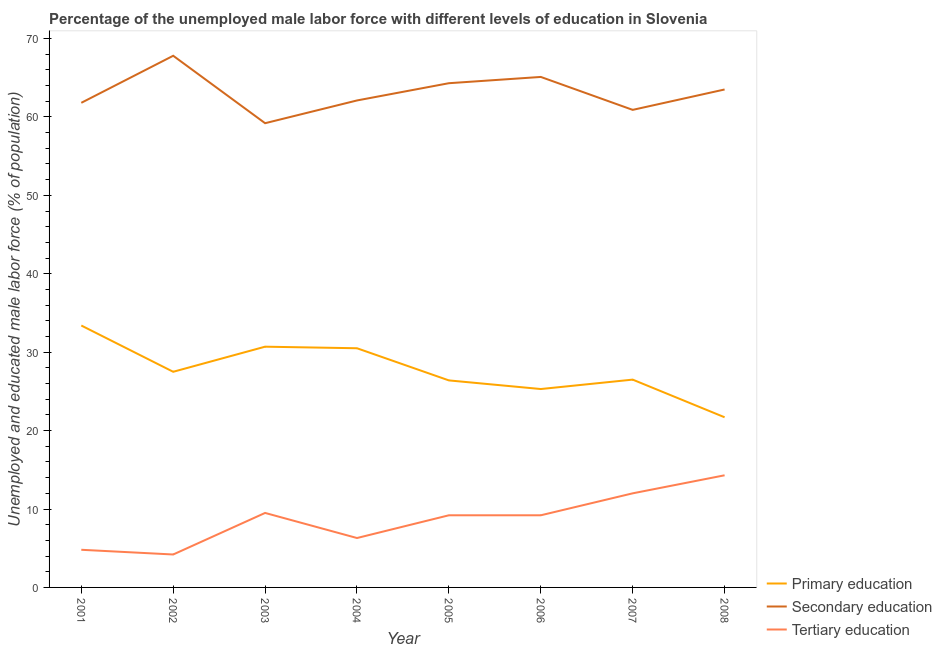How many different coloured lines are there?
Your response must be concise. 3. Across all years, what is the maximum percentage of male labor force who received secondary education?
Your response must be concise. 67.8. Across all years, what is the minimum percentage of male labor force who received secondary education?
Provide a succinct answer. 59.2. In which year was the percentage of male labor force who received secondary education maximum?
Your answer should be very brief. 2002. In which year was the percentage of male labor force who received tertiary education minimum?
Give a very brief answer. 2002. What is the total percentage of male labor force who received primary education in the graph?
Offer a very short reply. 222. What is the difference between the percentage of male labor force who received tertiary education in 2004 and that in 2007?
Offer a terse response. -5.7. What is the difference between the percentage of male labor force who received tertiary education in 2008 and the percentage of male labor force who received primary education in 2003?
Ensure brevity in your answer.  -16.4. What is the average percentage of male labor force who received secondary education per year?
Offer a terse response. 63.09. In the year 2002, what is the difference between the percentage of male labor force who received primary education and percentage of male labor force who received secondary education?
Ensure brevity in your answer.  -40.3. In how many years, is the percentage of male labor force who received tertiary education greater than 40 %?
Keep it short and to the point. 0. What is the ratio of the percentage of male labor force who received tertiary education in 2001 to that in 2004?
Keep it short and to the point. 0.76. Is the percentage of male labor force who received tertiary education in 2004 less than that in 2007?
Keep it short and to the point. Yes. What is the difference between the highest and the second highest percentage of male labor force who received secondary education?
Give a very brief answer. 2.7. What is the difference between the highest and the lowest percentage of male labor force who received tertiary education?
Provide a succinct answer. 10.1. Is the sum of the percentage of male labor force who received tertiary education in 2003 and 2007 greater than the maximum percentage of male labor force who received secondary education across all years?
Offer a terse response. No. Does the percentage of male labor force who received primary education monotonically increase over the years?
Provide a succinct answer. No. Is the percentage of male labor force who received tertiary education strictly less than the percentage of male labor force who received primary education over the years?
Keep it short and to the point. Yes. How many lines are there?
Provide a short and direct response. 3. Are the values on the major ticks of Y-axis written in scientific E-notation?
Make the answer very short. No. Does the graph contain any zero values?
Your answer should be very brief. No. Does the graph contain grids?
Your response must be concise. No. What is the title of the graph?
Provide a short and direct response. Percentage of the unemployed male labor force with different levels of education in Slovenia. What is the label or title of the X-axis?
Provide a short and direct response. Year. What is the label or title of the Y-axis?
Offer a very short reply. Unemployed and educated male labor force (% of population). What is the Unemployed and educated male labor force (% of population) in Primary education in 2001?
Your answer should be compact. 33.4. What is the Unemployed and educated male labor force (% of population) in Secondary education in 2001?
Offer a very short reply. 61.8. What is the Unemployed and educated male labor force (% of population) in Tertiary education in 2001?
Offer a terse response. 4.8. What is the Unemployed and educated male labor force (% of population) in Secondary education in 2002?
Make the answer very short. 67.8. What is the Unemployed and educated male labor force (% of population) of Tertiary education in 2002?
Your response must be concise. 4.2. What is the Unemployed and educated male labor force (% of population) in Primary education in 2003?
Offer a very short reply. 30.7. What is the Unemployed and educated male labor force (% of population) of Secondary education in 2003?
Your answer should be compact. 59.2. What is the Unemployed and educated male labor force (% of population) in Primary education in 2004?
Your answer should be compact. 30.5. What is the Unemployed and educated male labor force (% of population) in Secondary education in 2004?
Keep it short and to the point. 62.1. What is the Unemployed and educated male labor force (% of population) in Tertiary education in 2004?
Keep it short and to the point. 6.3. What is the Unemployed and educated male labor force (% of population) in Primary education in 2005?
Offer a very short reply. 26.4. What is the Unemployed and educated male labor force (% of population) of Secondary education in 2005?
Your response must be concise. 64.3. What is the Unemployed and educated male labor force (% of population) in Tertiary education in 2005?
Your answer should be compact. 9.2. What is the Unemployed and educated male labor force (% of population) of Primary education in 2006?
Keep it short and to the point. 25.3. What is the Unemployed and educated male labor force (% of population) of Secondary education in 2006?
Offer a very short reply. 65.1. What is the Unemployed and educated male labor force (% of population) in Tertiary education in 2006?
Provide a succinct answer. 9.2. What is the Unemployed and educated male labor force (% of population) in Secondary education in 2007?
Provide a succinct answer. 60.9. What is the Unemployed and educated male labor force (% of population) of Primary education in 2008?
Your answer should be very brief. 21.7. What is the Unemployed and educated male labor force (% of population) in Secondary education in 2008?
Keep it short and to the point. 63.5. What is the Unemployed and educated male labor force (% of population) in Tertiary education in 2008?
Your response must be concise. 14.3. Across all years, what is the maximum Unemployed and educated male labor force (% of population) in Primary education?
Your answer should be compact. 33.4. Across all years, what is the maximum Unemployed and educated male labor force (% of population) of Secondary education?
Make the answer very short. 67.8. Across all years, what is the maximum Unemployed and educated male labor force (% of population) in Tertiary education?
Provide a succinct answer. 14.3. Across all years, what is the minimum Unemployed and educated male labor force (% of population) in Primary education?
Offer a terse response. 21.7. Across all years, what is the minimum Unemployed and educated male labor force (% of population) in Secondary education?
Keep it short and to the point. 59.2. Across all years, what is the minimum Unemployed and educated male labor force (% of population) of Tertiary education?
Ensure brevity in your answer.  4.2. What is the total Unemployed and educated male labor force (% of population) of Primary education in the graph?
Your answer should be very brief. 222. What is the total Unemployed and educated male labor force (% of population) of Secondary education in the graph?
Offer a terse response. 504.7. What is the total Unemployed and educated male labor force (% of population) of Tertiary education in the graph?
Provide a short and direct response. 69.5. What is the difference between the Unemployed and educated male labor force (% of population) of Secondary education in 2001 and that in 2002?
Give a very brief answer. -6. What is the difference between the Unemployed and educated male labor force (% of population) of Secondary education in 2001 and that in 2003?
Offer a very short reply. 2.6. What is the difference between the Unemployed and educated male labor force (% of population) of Tertiary education in 2001 and that in 2003?
Provide a succinct answer. -4.7. What is the difference between the Unemployed and educated male labor force (% of population) in Secondary education in 2001 and that in 2004?
Provide a short and direct response. -0.3. What is the difference between the Unemployed and educated male labor force (% of population) of Secondary education in 2001 and that in 2005?
Your answer should be compact. -2.5. What is the difference between the Unemployed and educated male labor force (% of population) in Tertiary education in 2001 and that in 2005?
Provide a succinct answer. -4.4. What is the difference between the Unemployed and educated male labor force (% of population) in Primary education in 2001 and that in 2006?
Offer a very short reply. 8.1. What is the difference between the Unemployed and educated male labor force (% of population) of Secondary education in 2001 and that in 2006?
Your answer should be compact. -3.3. What is the difference between the Unemployed and educated male labor force (% of population) in Secondary education in 2001 and that in 2007?
Offer a very short reply. 0.9. What is the difference between the Unemployed and educated male labor force (% of population) of Tertiary education in 2001 and that in 2007?
Make the answer very short. -7.2. What is the difference between the Unemployed and educated male labor force (% of population) of Primary education in 2001 and that in 2008?
Ensure brevity in your answer.  11.7. What is the difference between the Unemployed and educated male labor force (% of population) of Tertiary education in 2002 and that in 2003?
Your response must be concise. -5.3. What is the difference between the Unemployed and educated male labor force (% of population) of Secondary education in 2002 and that in 2004?
Make the answer very short. 5.7. What is the difference between the Unemployed and educated male labor force (% of population) in Tertiary education in 2002 and that in 2004?
Your answer should be very brief. -2.1. What is the difference between the Unemployed and educated male labor force (% of population) in Secondary education in 2002 and that in 2005?
Your answer should be compact. 3.5. What is the difference between the Unemployed and educated male labor force (% of population) in Primary education in 2002 and that in 2006?
Make the answer very short. 2.2. What is the difference between the Unemployed and educated male labor force (% of population) in Primary education in 2002 and that in 2007?
Ensure brevity in your answer.  1. What is the difference between the Unemployed and educated male labor force (% of population) of Secondary education in 2002 and that in 2007?
Keep it short and to the point. 6.9. What is the difference between the Unemployed and educated male labor force (% of population) of Primary education in 2002 and that in 2008?
Your answer should be compact. 5.8. What is the difference between the Unemployed and educated male labor force (% of population) in Secondary education in 2002 and that in 2008?
Your answer should be very brief. 4.3. What is the difference between the Unemployed and educated male labor force (% of population) in Tertiary education in 2002 and that in 2008?
Ensure brevity in your answer.  -10.1. What is the difference between the Unemployed and educated male labor force (% of population) of Secondary education in 2003 and that in 2004?
Provide a succinct answer. -2.9. What is the difference between the Unemployed and educated male labor force (% of population) of Tertiary education in 2003 and that in 2004?
Offer a very short reply. 3.2. What is the difference between the Unemployed and educated male labor force (% of population) of Tertiary education in 2003 and that in 2005?
Offer a terse response. 0.3. What is the difference between the Unemployed and educated male labor force (% of population) in Primary education in 2003 and that in 2006?
Keep it short and to the point. 5.4. What is the difference between the Unemployed and educated male labor force (% of population) in Secondary education in 2003 and that in 2006?
Keep it short and to the point. -5.9. What is the difference between the Unemployed and educated male labor force (% of population) in Primary education in 2003 and that in 2007?
Make the answer very short. 4.2. What is the difference between the Unemployed and educated male labor force (% of population) in Secondary education in 2003 and that in 2007?
Offer a terse response. -1.7. What is the difference between the Unemployed and educated male labor force (% of population) in Tertiary education in 2003 and that in 2007?
Ensure brevity in your answer.  -2.5. What is the difference between the Unemployed and educated male labor force (% of population) in Primary education in 2003 and that in 2008?
Provide a succinct answer. 9. What is the difference between the Unemployed and educated male labor force (% of population) in Secondary education in 2003 and that in 2008?
Give a very brief answer. -4.3. What is the difference between the Unemployed and educated male labor force (% of population) in Tertiary education in 2003 and that in 2008?
Provide a short and direct response. -4.8. What is the difference between the Unemployed and educated male labor force (% of population) in Primary education in 2004 and that in 2005?
Give a very brief answer. 4.1. What is the difference between the Unemployed and educated male labor force (% of population) of Secondary education in 2004 and that in 2006?
Provide a succinct answer. -3. What is the difference between the Unemployed and educated male labor force (% of population) of Primary education in 2004 and that in 2007?
Provide a succinct answer. 4. What is the difference between the Unemployed and educated male labor force (% of population) of Secondary education in 2004 and that in 2007?
Ensure brevity in your answer.  1.2. What is the difference between the Unemployed and educated male labor force (% of population) in Tertiary education in 2004 and that in 2007?
Offer a very short reply. -5.7. What is the difference between the Unemployed and educated male labor force (% of population) of Secondary education in 2004 and that in 2008?
Give a very brief answer. -1.4. What is the difference between the Unemployed and educated male labor force (% of population) of Tertiary education in 2004 and that in 2008?
Give a very brief answer. -8. What is the difference between the Unemployed and educated male labor force (% of population) of Secondary education in 2005 and that in 2006?
Keep it short and to the point. -0.8. What is the difference between the Unemployed and educated male labor force (% of population) of Secondary education in 2005 and that in 2007?
Offer a very short reply. 3.4. What is the difference between the Unemployed and educated male labor force (% of population) of Tertiary education in 2005 and that in 2007?
Your answer should be compact. -2.8. What is the difference between the Unemployed and educated male labor force (% of population) of Tertiary education in 2005 and that in 2008?
Provide a short and direct response. -5.1. What is the difference between the Unemployed and educated male labor force (% of population) in Primary education in 2006 and that in 2007?
Provide a succinct answer. -1.2. What is the difference between the Unemployed and educated male labor force (% of population) of Secondary education in 2006 and that in 2008?
Your answer should be compact. 1.6. What is the difference between the Unemployed and educated male labor force (% of population) in Secondary education in 2007 and that in 2008?
Offer a very short reply. -2.6. What is the difference between the Unemployed and educated male labor force (% of population) of Primary education in 2001 and the Unemployed and educated male labor force (% of population) of Secondary education in 2002?
Your response must be concise. -34.4. What is the difference between the Unemployed and educated male labor force (% of population) in Primary education in 2001 and the Unemployed and educated male labor force (% of population) in Tertiary education in 2002?
Offer a very short reply. 29.2. What is the difference between the Unemployed and educated male labor force (% of population) in Secondary education in 2001 and the Unemployed and educated male labor force (% of population) in Tertiary education in 2002?
Offer a terse response. 57.6. What is the difference between the Unemployed and educated male labor force (% of population) of Primary education in 2001 and the Unemployed and educated male labor force (% of population) of Secondary education in 2003?
Your response must be concise. -25.8. What is the difference between the Unemployed and educated male labor force (% of population) in Primary education in 2001 and the Unemployed and educated male labor force (% of population) in Tertiary education in 2003?
Your answer should be very brief. 23.9. What is the difference between the Unemployed and educated male labor force (% of population) in Secondary education in 2001 and the Unemployed and educated male labor force (% of population) in Tertiary education in 2003?
Your answer should be very brief. 52.3. What is the difference between the Unemployed and educated male labor force (% of population) in Primary education in 2001 and the Unemployed and educated male labor force (% of population) in Secondary education in 2004?
Provide a succinct answer. -28.7. What is the difference between the Unemployed and educated male labor force (% of population) in Primary education in 2001 and the Unemployed and educated male labor force (% of population) in Tertiary education in 2004?
Keep it short and to the point. 27.1. What is the difference between the Unemployed and educated male labor force (% of population) in Secondary education in 2001 and the Unemployed and educated male labor force (% of population) in Tertiary education in 2004?
Give a very brief answer. 55.5. What is the difference between the Unemployed and educated male labor force (% of population) of Primary education in 2001 and the Unemployed and educated male labor force (% of population) of Secondary education in 2005?
Your answer should be compact. -30.9. What is the difference between the Unemployed and educated male labor force (% of population) in Primary education in 2001 and the Unemployed and educated male labor force (% of population) in Tertiary education in 2005?
Offer a very short reply. 24.2. What is the difference between the Unemployed and educated male labor force (% of population) of Secondary education in 2001 and the Unemployed and educated male labor force (% of population) of Tertiary education in 2005?
Provide a short and direct response. 52.6. What is the difference between the Unemployed and educated male labor force (% of population) of Primary education in 2001 and the Unemployed and educated male labor force (% of population) of Secondary education in 2006?
Offer a very short reply. -31.7. What is the difference between the Unemployed and educated male labor force (% of population) of Primary education in 2001 and the Unemployed and educated male labor force (% of population) of Tertiary education in 2006?
Your answer should be compact. 24.2. What is the difference between the Unemployed and educated male labor force (% of population) of Secondary education in 2001 and the Unemployed and educated male labor force (% of population) of Tertiary education in 2006?
Offer a terse response. 52.6. What is the difference between the Unemployed and educated male labor force (% of population) in Primary education in 2001 and the Unemployed and educated male labor force (% of population) in Secondary education in 2007?
Provide a short and direct response. -27.5. What is the difference between the Unemployed and educated male labor force (% of population) in Primary education in 2001 and the Unemployed and educated male labor force (% of population) in Tertiary education in 2007?
Keep it short and to the point. 21.4. What is the difference between the Unemployed and educated male labor force (% of population) of Secondary education in 2001 and the Unemployed and educated male labor force (% of population) of Tertiary education in 2007?
Offer a terse response. 49.8. What is the difference between the Unemployed and educated male labor force (% of population) of Primary education in 2001 and the Unemployed and educated male labor force (% of population) of Secondary education in 2008?
Keep it short and to the point. -30.1. What is the difference between the Unemployed and educated male labor force (% of population) in Secondary education in 2001 and the Unemployed and educated male labor force (% of population) in Tertiary education in 2008?
Provide a short and direct response. 47.5. What is the difference between the Unemployed and educated male labor force (% of population) of Primary education in 2002 and the Unemployed and educated male labor force (% of population) of Secondary education in 2003?
Your answer should be very brief. -31.7. What is the difference between the Unemployed and educated male labor force (% of population) in Secondary education in 2002 and the Unemployed and educated male labor force (% of population) in Tertiary education in 2003?
Make the answer very short. 58.3. What is the difference between the Unemployed and educated male labor force (% of population) of Primary education in 2002 and the Unemployed and educated male labor force (% of population) of Secondary education in 2004?
Provide a short and direct response. -34.6. What is the difference between the Unemployed and educated male labor force (% of population) of Primary education in 2002 and the Unemployed and educated male labor force (% of population) of Tertiary education in 2004?
Your response must be concise. 21.2. What is the difference between the Unemployed and educated male labor force (% of population) of Secondary education in 2002 and the Unemployed and educated male labor force (% of population) of Tertiary education in 2004?
Keep it short and to the point. 61.5. What is the difference between the Unemployed and educated male labor force (% of population) of Primary education in 2002 and the Unemployed and educated male labor force (% of population) of Secondary education in 2005?
Provide a succinct answer. -36.8. What is the difference between the Unemployed and educated male labor force (% of population) in Secondary education in 2002 and the Unemployed and educated male labor force (% of population) in Tertiary education in 2005?
Your answer should be very brief. 58.6. What is the difference between the Unemployed and educated male labor force (% of population) of Primary education in 2002 and the Unemployed and educated male labor force (% of population) of Secondary education in 2006?
Your answer should be compact. -37.6. What is the difference between the Unemployed and educated male labor force (% of population) in Secondary education in 2002 and the Unemployed and educated male labor force (% of population) in Tertiary education in 2006?
Your answer should be very brief. 58.6. What is the difference between the Unemployed and educated male labor force (% of population) in Primary education in 2002 and the Unemployed and educated male labor force (% of population) in Secondary education in 2007?
Provide a succinct answer. -33.4. What is the difference between the Unemployed and educated male labor force (% of population) in Primary education in 2002 and the Unemployed and educated male labor force (% of population) in Tertiary education in 2007?
Your answer should be very brief. 15.5. What is the difference between the Unemployed and educated male labor force (% of population) in Secondary education in 2002 and the Unemployed and educated male labor force (% of population) in Tertiary education in 2007?
Offer a terse response. 55.8. What is the difference between the Unemployed and educated male labor force (% of population) in Primary education in 2002 and the Unemployed and educated male labor force (% of population) in Secondary education in 2008?
Your answer should be compact. -36. What is the difference between the Unemployed and educated male labor force (% of population) of Primary education in 2002 and the Unemployed and educated male labor force (% of population) of Tertiary education in 2008?
Your answer should be very brief. 13.2. What is the difference between the Unemployed and educated male labor force (% of population) in Secondary education in 2002 and the Unemployed and educated male labor force (% of population) in Tertiary education in 2008?
Make the answer very short. 53.5. What is the difference between the Unemployed and educated male labor force (% of population) in Primary education in 2003 and the Unemployed and educated male labor force (% of population) in Secondary education in 2004?
Offer a very short reply. -31.4. What is the difference between the Unemployed and educated male labor force (% of population) of Primary education in 2003 and the Unemployed and educated male labor force (% of population) of Tertiary education in 2004?
Offer a terse response. 24.4. What is the difference between the Unemployed and educated male labor force (% of population) of Secondary education in 2003 and the Unemployed and educated male labor force (% of population) of Tertiary education in 2004?
Your response must be concise. 52.9. What is the difference between the Unemployed and educated male labor force (% of population) of Primary education in 2003 and the Unemployed and educated male labor force (% of population) of Secondary education in 2005?
Give a very brief answer. -33.6. What is the difference between the Unemployed and educated male labor force (% of population) in Secondary education in 2003 and the Unemployed and educated male labor force (% of population) in Tertiary education in 2005?
Your answer should be compact. 50. What is the difference between the Unemployed and educated male labor force (% of population) in Primary education in 2003 and the Unemployed and educated male labor force (% of population) in Secondary education in 2006?
Keep it short and to the point. -34.4. What is the difference between the Unemployed and educated male labor force (% of population) of Primary education in 2003 and the Unemployed and educated male labor force (% of population) of Secondary education in 2007?
Your answer should be very brief. -30.2. What is the difference between the Unemployed and educated male labor force (% of population) in Secondary education in 2003 and the Unemployed and educated male labor force (% of population) in Tertiary education in 2007?
Your answer should be very brief. 47.2. What is the difference between the Unemployed and educated male labor force (% of population) of Primary education in 2003 and the Unemployed and educated male labor force (% of population) of Secondary education in 2008?
Ensure brevity in your answer.  -32.8. What is the difference between the Unemployed and educated male labor force (% of population) in Secondary education in 2003 and the Unemployed and educated male labor force (% of population) in Tertiary education in 2008?
Ensure brevity in your answer.  44.9. What is the difference between the Unemployed and educated male labor force (% of population) of Primary education in 2004 and the Unemployed and educated male labor force (% of population) of Secondary education in 2005?
Give a very brief answer. -33.8. What is the difference between the Unemployed and educated male labor force (% of population) in Primary education in 2004 and the Unemployed and educated male labor force (% of population) in Tertiary education in 2005?
Make the answer very short. 21.3. What is the difference between the Unemployed and educated male labor force (% of population) of Secondary education in 2004 and the Unemployed and educated male labor force (% of population) of Tertiary education in 2005?
Your answer should be compact. 52.9. What is the difference between the Unemployed and educated male labor force (% of population) of Primary education in 2004 and the Unemployed and educated male labor force (% of population) of Secondary education in 2006?
Your response must be concise. -34.6. What is the difference between the Unemployed and educated male labor force (% of population) of Primary education in 2004 and the Unemployed and educated male labor force (% of population) of Tertiary education in 2006?
Your answer should be compact. 21.3. What is the difference between the Unemployed and educated male labor force (% of population) of Secondary education in 2004 and the Unemployed and educated male labor force (% of population) of Tertiary education in 2006?
Offer a very short reply. 52.9. What is the difference between the Unemployed and educated male labor force (% of population) of Primary education in 2004 and the Unemployed and educated male labor force (% of population) of Secondary education in 2007?
Provide a succinct answer. -30.4. What is the difference between the Unemployed and educated male labor force (% of population) in Secondary education in 2004 and the Unemployed and educated male labor force (% of population) in Tertiary education in 2007?
Provide a short and direct response. 50.1. What is the difference between the Unemployed and educated male labor force (% of population) in Primary education in 2004 and the Unemployed and educated male labor force (% of population) in Secondary education in 2008?
Your response must be concise. -33. What is the difference between the Unemployed and educated male labor force (% of population) in Secondary education in 2004 and the Unemployed and educated male labor force (% of population) in Tertiary education in 2008?
Make the answer very short. 47.8. What is the difference between the Unemployed and educated male labor force (% of population) of Primary education in 2005 and the Unemployed and educated male labor force (% of population) of Secondary education in 2006?
Your response must be concise. -38.7. What is the difference between the Unemployed and educated male labor force (% of population) in Secondary education in 2005 and the Unemployed and educated male labor force (% of population) in Tertiary education in 2006?
Provide a short and direct response. 55.1. What is the difference between the Unemployed and educated male labor force (% of population) of Primary education in 2005 and the Unemployed and educated male labor force (% of population) of Secondary education in 2007?
Provide a short and direct response. -34.5. What is the difference between the Unemployed and educated male labor force (% of population) in Secondary education in 2005 and the Unemployed and educated male labor force (% of population) in Tertiary education in 2007?
Offer a very short reply. 52.3. What is the difference between the Unemployed and educated male labor force (% of population) in Primary education in 2005 and the Unemployed and educated male labor force (% of population) in Secondary education in 2008?
Your answer should be compact. -37.1. What is the difference between the Unemployed and educated male labor force (% of population) of Primary education in 2005 and the Unemployed and educated male labor force (% of population) of Tertiary education in 2008?
Provide a short and direct response. 12.1. What is the difference between the Unemployed and educated male labor force (% of population) of Primary education in 2006 and the Unemployed and educated male labor force (% of population) of Secondary education in 2007?
Provide a succinct answer. -35.6. What is the difference between the Unemployed and educated male labor force (% of population) in Primary education in 2006 and the Unemployed and educated male labor force (% of population) in Tertiary education in 2007?
Offer a terse response. 13.3. What is the difference between the Unemployed and educated male labor force (% of population) of Secondary education in 2006 and the Unemployed and educated male labor force (% of population) of Tertiary education in 2007?
Provide a short and direct response. 53.1. What is the difference between the Unemployed and educated male labor force (% of population) in Primary education in 2006 and the Unemployed and educated male labor force (% of population) in Secondary education in 2008?
Provide a short and direct response. -38.2. What is the difference between the Unemployed and educated male labor force (% of population) of Primary education in 2006 and the Unemployed and educated male labor force (% of population) of Tertiary education in 2008?
Your answer should be very brief. 11. What is the difference between the Unemployed and educated male labor force (% of population) in Secondary education in 2006 and the Unemployed and educated male labor force (% of population) in Tertiary education in 2008?
Provide a succinct answer. 50.8. What is the difference between the Unemployed and educated male labor force (% of population) of Primary education in 2007 and the Unemployed and educated male labor force (% of population) of Secondary education in 2008?
Your answer should be compact. -37. What is the difference between the Unemployed and educated male labor force (% of population) in Primary education in 2007 and the Unemployed and educated male labor force (% of population) in Tertiary education in 2008?
Provide a short and direct response. 12.2. What is the difference between the Unemployed and educated male labor force (% of population) in Secondary education in 2007 and the Unemployed and educated male labor force (% of population) in Tertiary education in 2008?
Keep it short and to the point. 46.6. What is the average Unemployed and educated male labor force (% of population) in Primary education per year?
Your answer should be compact. 27.75. What is the average Unemployed and educated male labor force (% of population) in Secondary education per year?
Make the answer very short. 63.09. What is the average Unemployed and educated male labor force (% of population) of Tertiary education per year?
Provide a succinct answer. 8.69. In the year 2001, what is the difference between the Unemployed and educated male labor force (% of population) in Primary education and Unemployed and educated male labor force (% of population) in Secondary education?
Provide a short and direct response. -28.4. In the year 2001, what is the difference between the Unemployed and educated male labor force (% of population) of Primary education and Unemployed and educated male labor force (% of population) of Tertiary education?
Offer a terse response. 28.6. In the year 2002, what is the difference between the Unemployed and educated male labor force (% of population) in Primary education and Unemployed and educated male labor force (% of population) in Secondary education?
Give a very brief answer. -40.3. In the year 2002, what is the difference between the Unemployed and educated male labor force (% of population) of Primary education and Unemployed and educated male labor force (% of population) of Tertiary education?
Your answer should be compact. 23.3. In the year 2002, what is the difference between the Unemployed and educated male labor force (% of population) in Secondary education and Unemployed and educated male labor force (% of population) in Tertiary education?
Offer a very short reply. 63.6. In the year 2003, what is the difference between the Unemployed and educated male labor force (% of population) in Primary education and Unemployed and educated male labor force (% of population) in Secondary education?
Offer a very short reply. -28.5. In the year 2003, what is the difference between the Unemployed and educated male labor force (% of population) in Primary education and Unemployed and educated male labor force (% of population) in Tertiary education?
Keep it short and to the point. 21.2. In the year 2003, what is the difference between the Unemployed and educated male labor force (% of population) in Secondary education and Unemployed and educated male labor force (% of population) in Tertiary education?
Your answer should be very brief. 49.7. In the year 2004, what is the difference between the Unemployed and educated male labor force (% of population) of Primary education and Unemployed and educated male labor force (% of population) of Secondary education?
Provide a short and direct response. -31.6. In the year 2004, what is the difference between the Unemployed and educated male labor force (% of population) in Primary education and Unemployed and educated male labor force (% of population) in Tertiary education?
Offer a terse response. 24.2. In the year 2004, what is the difference between the Unemployed and educated male labor force (% of population) in Secondary education and Unemployed and educated male labor force (% of population) in Tertiary education?
Offer a very short reply. 55.8. In the year 2005, what is the difference between the Unemployed and educated male labor force (% of population) of Primary education and Unemployed and educated male labor force (% of population) of Secondary education?
Your answer should be very brief. -37.9. In the year 2005, what is the difference between the Unemployed and educated male labor force (% of population) of Primary education and Unemployed and educated male labor force (% of population) of Tertiary education?
Your answer should be very brief. 17.2. In the year 2005, what is the difference between the Unemployed and educated male labor force (% of population) in Secondary education and Unemployed and educated male labor force (% of population) in Tertiary education?
Offer a very short reply. 55.1. In the year 2006, what is the difference between the Unemployed and educated male labor force (% of population) in Primary education and Unemployed and educated male labor force (% of population) in Secondary education?
Keep it short and to the point. -39.8. In the year 2006, what is the difference between the Unemployed and educated male labor force (% of population) in Primary education and Unemployed and educated male labor force (% of population) in Tertiary education?
Provide a succinct answer. 16.1. In the year 2006, what is the difference between the Unemployed and educated male labor force (% of population) in Secondary education and Unemployed and educated male labor force (% of population) in Tertiary education?
Ensure brevity in your answer.  55.9. In the year 2007, what is the difference between the Unemployed and educated male labor force (% of population) in Primary education and Unemployed and educated male labor force (% of population) in Secondary education?
Make the answer very short. -34.4. In the year 2007, what is the difference between the Unemployed and educated male labor force (% of population) of Secondary education and Unemployed and educated male labor force (% of population) of Tertiary education?
Ensure brevity in your answer.  48.9. In the year 2008, what is the difference between the Unemployed and educated male labor force (% of population) in Primary education and Unemployed and educated male labor force (% of population) in Secondary education?
Provide a short and direct response. -41.8. In the year 2008, what is the difference between the Unemployed and educated male labor force (% of population) of Primary education and Unemployed and educated male labor force (% of population) of Tertiary education?
Give a very brief answer. 7.4. In the year 2008, what is the difference between the Unemployed and educated male labor force (% of population) of Secondary education and Unemployed and educated male labor force (% of population) of Tertiary education?
Give a very brief answer. 49.2. What is the ratio of the Unemployed and educated male labor force (% of population) of Primary education in 2001 to that in 2002?
Your answer should be very brief. 1.21. What is the ratio of the Unemployed and educated male labor force (% of population) in Secondary education in 2001 to that in 2002?
Provide a short and direct response. 0.91. What is the ratio of the Unemployed and educated male labor force (% of population) in Primary education in 2001 to that in 2003?
Offer a very short reply. 1.09. What is the ratio of the Unemployed and educated male labor force (% of population) of Secondary education in 2001 to that in 2003?
Ensure brevity in your answer.  1.04. What is the ratio of the Unemployed and educated male labor force (% of population) of Tertiary education in 2001 to that in 2003?
Your answer should be very brief. 0.51. What is the ratio of the Unemployed and educated male labor force (% of population) in Primary education in 2001 to that in 2004?
Your response must be concise. 1.1. What is the ratio of the Unemployed and educated male labor force (% of population) of Secondary education in 2001 to that in 2004?
Ensure brevity in your answer.  1. What is the ratio of the Unemployed and educated male labor force (% of population) in Tertiary education in 2001 to that in 2004?
Your answer should be compact. 0.76. What is the ratio of the Unemployed and educated male labor force (% of population) in Primary education in 2001 to that in 2005?
Your answer should be very brief. 1.27. What is the ratio of the Unemployed and educated male labor force (% of population) in Secondary education in 2001 to that in 2005?
Provide a short and direct response. 0.96. What is the ratio of the Unemployed and educated male labor force (% of population) of Tertiary education in 2001 to that in 2005?
Your response must be concise. 0.52. What is the ratio of the Unemployed and educated male labor force (% of population) of Primary education in 2001 to that in 2006?
Keep it short and to the point. 1.32. What is the ratio of the Unemployed and educated male labor force (% of population) in Secondary education in 2001 to that in 2006?
Your answer should be very brief. 0.95. What is the ratio of the Unemployed and educated male labor force (% of population) in Tertiary education in 2001 to that in 2006?
Offer a very short reply. 0.52. What is the ratio of the Unemployed and educated male labor force (% of population) of Primary education in 2001 to that in 2007?
Offer a very short reply. 1.26. What is the ratio of the Unemployed and educated male labor force (% of population) in Secondary education in 2001 to that in 2007?
Offer a very short reply. 1.01. What is the ratio of the Unemployed and educated male labor force (% of population) of Primary education in 2001 to that in 2008?
Offer a very short reply. 1.54. What is the ratio of the Unemployed and educated male labor force (% of population) of Secondary education in 2001 to that in 2008?
Provide a short and direct response. 0.97. What is the ratio of the Unemployed and educated male labor force (% of population) of Tertiary education in 2001 to that in 2008?
Make the answer very short. 0.34. What is the ratio of the Unemployed and educated male labor force (% of population) in Primary education in 2002 to that in 2003?
Ensure brevity in your answer.  0.9. What is the ratio of the Unemployed and educated male labor force (% of population) in Secondary education in 2002 to that in 2003?
Your answer should be very brief. 1.15. What is the ratio of the Unemployed and educated male labor force (% of population) in Tertiary education in 2002 to that in 2003?
Provide a succinct answer. 0.44. What is the ratio of the Unemployed and educated male labor force (% of population) of Primary education in 2002 to that in 2004?
Provide a succinct answer. 0.9. What is the ratio of the Unemployed and educated male labor force (% of population) in Secondary education in 2002 to that in 2004?
Give a very brief answer. 1.09. What is the ratio of the Unemployed and educated male labor force (% of population) of Primary education in 2002 to that in 2005?
Your answer should be very brief. 1.04. What is the ratio of the Unemployed and educated male labor force (% of population) of Secondary education in 2002 to that in 2005?
Your response must be concise. 1.05. What is the ratio of the Unemployed and educated male labor force (% of population) in Tertiary education in 2002 to that in 2005?
Offer a terse response. 0.46. What is the ratio of the Unemployed and educated male labor force (% of population) of Primary education in 2002 to that in 2006?
Your response must be concise. 1.09. What is the ratio of the Unemployed and educated male labor force (% of population) in Secondary education in 2002 to that in 2006?
Ensure brevity in your answer.  1.04. What is the ratio of the Unemployed and educated male labor force (% of population) of Tertiary education in 2002 to that in 2006?
Provide a short and direct response. 0.46. What is the ratio of the Unemployed and educated male labor force (% of population) of Primary education in 2002 to that in 2007?
Your answer should be very brief. 1.04. What is the ratio of the Unemployed and educated male labor force (% of population) in Secondary education in 2002 to that in 2007?
Provide a succinct answer. 1.11. What is the ratio of the Unemployed and educated male labor force (% of population) of Tertiary education in 2002 to that in 2007?
Make the answer very short. 0.35. What is the ratio of the Unemployed and educated male labor force (% of population) of Primary education in 2002 to that in 2008?
Your response must be concise. 1.27. What is the ratio of the Unemployed and educated male labor force (% of population) of Secondary education in 2002 to that in 2008?
Your answer should be compact. 1.07. What is the ratio of the Unemployed and educated male labor force (% of population) of Tertiary education in 2002 to that in 2008?
Keep it short and to the point. 0.29. What is the ratio of the Unemployed and educated male labor force (% of population) of Primary education in 2003 to that in 2004?
Offer a very short reply. 1.01. What is the ratio of the Unemployed and educated male labor force (% of population) in Secondary education in 2003 to that in 2004?
Offer a terse response. 0.95. What is the ratio of the Unemployed and educated male labor force (% of population) in Tertiary education in 2003 to that in 2004?
Make the answer very short. 1.51. What is the ratio of the Unemployed and educated male labor force (% of population) of Primary education in 2003 to that in 2005?
Offer a terse response. 1.16. What is the ratio of the Unemployed and educated male labor force (% of population) of Secondary education in 2003 to that in 2005?
Give a very brief answer. 0.92. What is the ratio of the Unemployed and educated male labor force (% of population) of Tertiary education in 2003 to that in 2005?
Provide a short and direct response. 1.03. What is the ratio of the Unemployed and educated male labor force (% of population) of Primary education in 2003 to that in 2006?
Keep it short and to the point. 1.21. What is the ratio of the Unemployed and educated male labor force (% of population) of Secondary education in 2003 to that in 2006?
Ensure brevity in your answer.  0.91. What is the ratio of the Unemployed and educated male labor force (% of population) of Tertiary education in 2003 to that in 2006?
Your answer should be very brief. 1.03. What is the ratio of the Unemployed and educated male labor force (% of population) in Primary education in 2003 to that in 2007?
Offer a terse response. 1.16. What is the ratio of the Unemployed and educated male labor force (% of population) in Secondary education in 2003 to that in 2007?
Give a very brief answer. 0.97. What is the ratio of the Unemployed and educated male labor force (% of population) of Tertiary education in 2003 to that in 2007?
Keep it short and to the point. 0.79. What is the ratio of the Unemployed and educated male labor force (% of population) in Primary education in 2003 to that in 2008?
Provide a short and direct response. 1.41. What is the ratio of the Unemployed and educated male labor force (% of population) in Secondary education in 2003 to that in 2008?
Provide a succinct answer. 0.93. What is the ratio of the Unemployed and educated male labor force (% of population) of Tertiary education in 2003 to that in 2008?
Provide a succinct answer. 0.66. What is the ratio of the Unemployed and educated male labor force (% of population) in Primary education in 2004 to that in 2005?
Offer a terse response. 1.16. What is the ratio of the Unemployed and educated male labor force (% of population) of Secondary education in 2004 to that in 2005?
Give a very brief answer. 0.97. What is the ratio of the Unemployed and educated male labor force (% of population) of Tertiary education in 2004 to that in 2005?
Your answer should be compact. 0.68. What is the ratio of the Unemployed and educated male labor force (% of population) of Primary education in 2004 to that in 2006?
Ensure brevity in your answer.  1.21. What is the ratio of the Unemployed and educated male labor force (% of population) in Secondary education in 2004 to that in 2006?
Your answer should be compact. 0.95. What is the ratio of the Unemployed and educated male labor force (% of population) of Tertiary education in 2004 to that in 2006?
Ensure brevity in your answer.  0.68. What is the ratio of the Unemployed and educated male labor force (% of population) in Primary education in 2004 to that in 2007?
Give a very brief answer. 1.15. What is the ratio of the Unemployed and educated male labor force (% of population) in Secondary education in 2004 to that in 2007?
Offer a very short reply. 1.02. What is the ratio of the Unemployed and educated male labor force (% of population) of Tertiary education in 2004 to that in 2007?
Your answer should be very brief. 0.53. What is the ratio of the Unemployed and educated male labor force (% of population) in Primary education in 2004 to that in 2008?
Offer a very short reply. 1.41. What is the ratio of the Unemployed and educated male labor force (% of population) in Secondary education in 2004 to that in 2008?
Your answer should be very brief. 0.98. What is the ratio of the Unemployed and educated male labor force (% of population) of Tertiary education in 2004 to that in 2008?
Provide a short and direct response. 0.44. What is the ratio of the Unemployed and educated male labor force (% of population) of Primary education in 2005 to that in 2006?
Give a very brief answer. 1.04. What is the ratio of the Unemployed and educated male labor force (% of population) in Secondary education in 2005 to that in 2006?
Offer a terse response. 0.99. What is the ratio of the Unemployed and educated male labor force (% of population) of Primary education in 2005 to that in 2007?
Offer a terse response. 1. What is the ratio of the Unemployed and educated male labor force (% of population) in Secondary education in 2005 to that in 2007?
Your response must be concise. 1.06. What is the ratio of the Unemployed and educated male labor force (% of population) of Tertiary education in 2005 to that in 2007?
Make the answer very short. 0.77. What is the ratio of the Unemployed and educated male labor force (% of population) in Primary education in 2005 to that in 2008?
Keep it short and to the point. 1.22. What is the ratio of the Unemployed and educated male labor force (% of population) of Secondary education in 2005 to that in 2008?
Ensure brevity in your answer.  1.01. What is the ratio of the Unemployed and educated male labor force (% of population) of Tertiary education in 2005 to that in 2008?
Make the answer very short. 0.64. What is the ratio of the Unemployed and educated male labor force (% of population) in Primary education in 2006 to that in 2007?
Your answer should be compact. 0.95. What is the ratio of the Unemployed and educated male labor force (% of population) of Secondary education in 2006 to that in 2007?
Make the answer very short. 1.07. What is the ratio of the Unemployed and educated male labor force (% of population) of Tertiary education in 2006 to that in 2007?
Your response must be concise. 0.77. What is the ratio of the Unemployed and educated male labor force (% of population) in Primary education in 2006 to that in 2008?
Your answer should be very brief. 1.17. What is the ratio of the Unemployed and educated male labor force (% of population) of Secondary education in 2006 to that in 2008?
Provide a succinct answer. 1.03. What is the ratio of the Unemployed and educated male labor force (% of population) of Tertiary education in 2006 to that in 2008?
Your response must be concise. 0.64. What is the ratio of the Unemployed and educated male labor force (% of population) of Primary education in 2007 to that in 2008?
Ensure brevity in your answer.  1.22. What is the ratio of the Unemployed and educated male labor force (% of population) of Secondary education in 2007 to that in 2008?
Your answer should be compact. 0.96. What is the ratio of the Unemployed and educated male labor force (% of population) of Tertiary education in 2007 to that in 2008?
Offer a very short reply. 0.84. What is the difference between the highest and the second highest Unemployed and educated male labor force (% of population) of Primary education?
Keep it short and to the point. 2.7. What is the difference between the highest and the second highest Unemployed and educated male labor force (% of population) in Tertiary education?
Provide a short and direct response. 2.3. What is the difference between the highest and the lowest Unemployed and educated male labor force (% of population) in Tertiary education?
Your response must be concise. 10.1. 